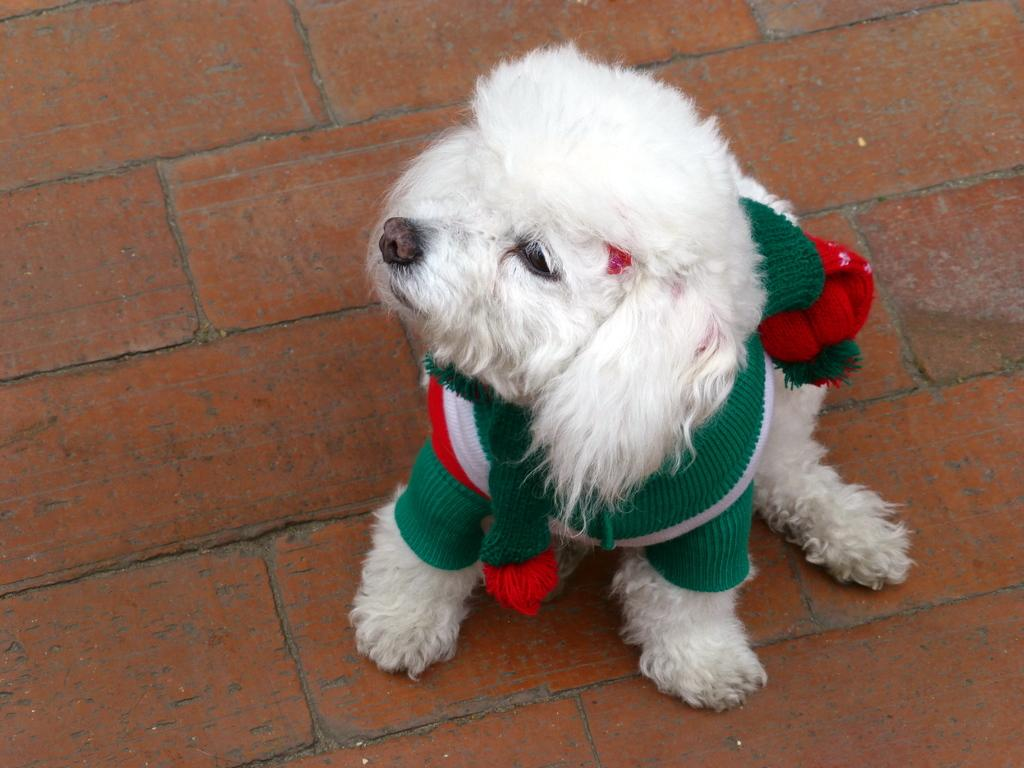What type of animal is in the image? There is a white color puppy in the image. Where is the puppy located in the image? The puppy is in the center of the image. What is the puppy wearing? The puppy appears to be wearing a sweater. Can you tell me how many oranges are on the receipt in the image? There is no receipt or oranges present in the image; it features a white color puppy wearing a sweater. 